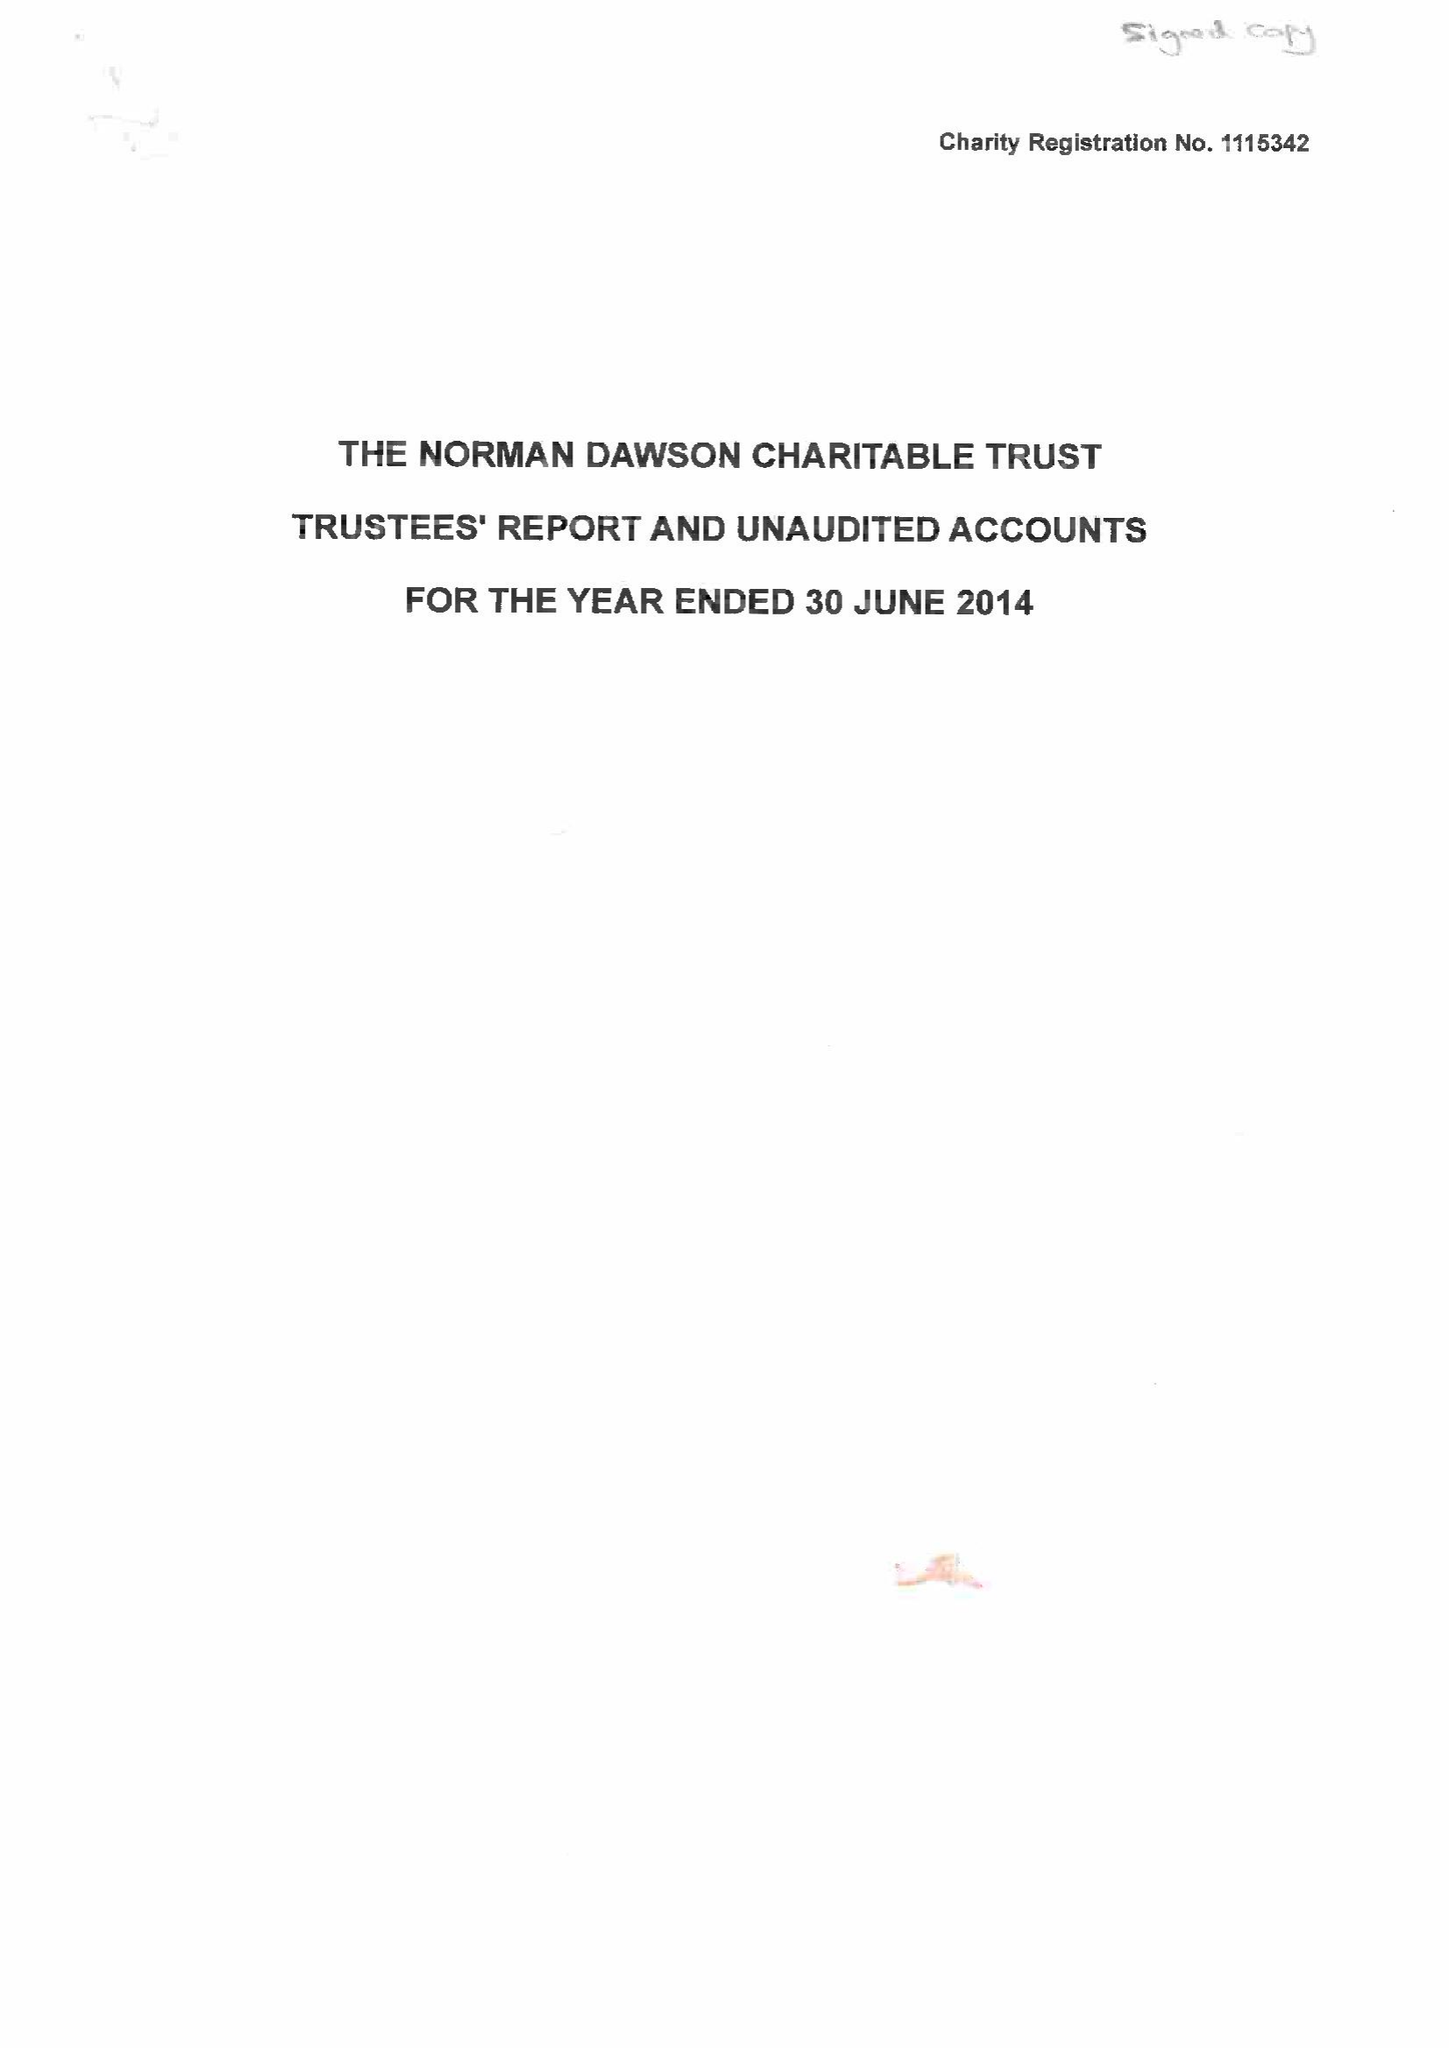What is the value for the address__postcode?
Answer the question using a single word or phrase. DY10 2SA 